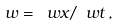<formula> <loc_0><loc_0><loc_500><loc_500>w = \ w x / \ w t \, ,</formula> 